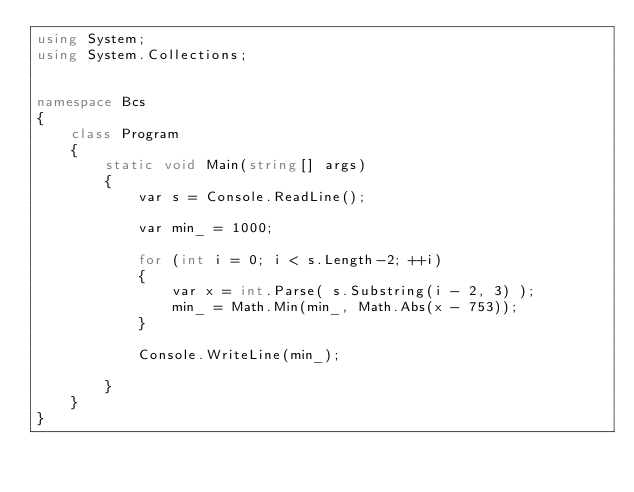Convert code to text. <code><loc_0><loc_0><loc_500><loc_500><_C#_>using System;
using System.Collections;


namespace Bcs
{
    class Program
    {
        static void Main(string[] args)
        {
            var s = Console.ReadLine();

            var min_ = 1000;

            for (int i = 0; i < s.Length-2; ++i)
            {
                var x = int.Parse( s.Substring(i - 2, 3) );
                min_ = Math.Min(min_, Math.Abs(x - 753));
            }

            Console.WriteLine(min_);

        }
    }
}
</code> 